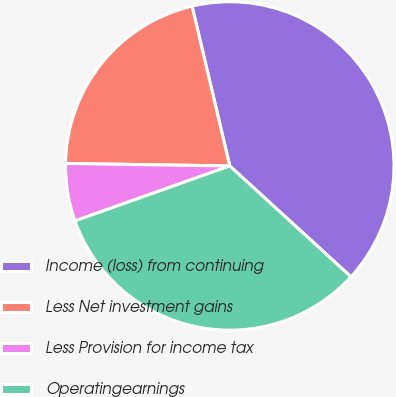Convert chart to OTSL. <chart><loc_0><loc_0><loc_500><loc_500><pie_chart><fcel>Income (loss) from continuing<fcel>Less Net investment gains<fcel>Less Provision for income tax<fcel>Operatingearnings<nl><fcel>40.48%<fcel>21.07%<fcel>5.67%<fcel>32.78%<nl></chart> 